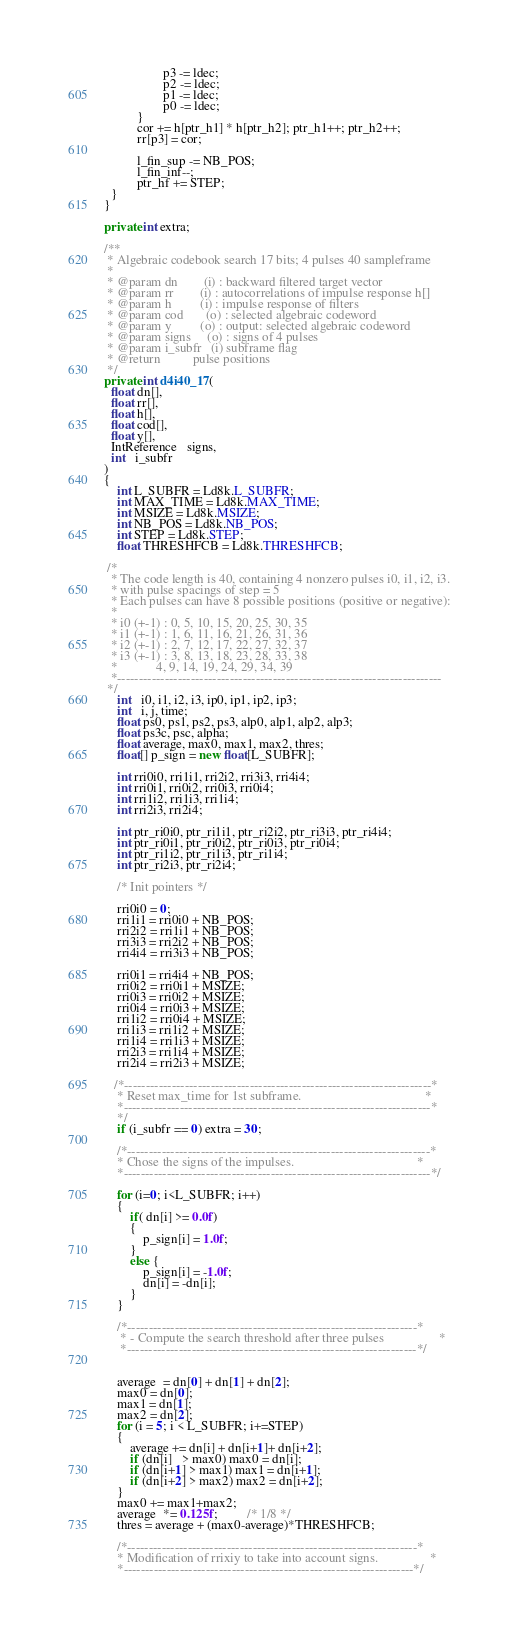<code> <loc_0><loc_0><loc_500><loc_500><_Java_>
                  p3 -= ldec;
                  p2 -= ldec;
                  p1 -= ldec;
                  p0 -= ldec;
          }
          cor += h[ptr_h1] * h[ptr_h2]; ptr_h1++; ptr_h2++;
          rr[p3] = cor;

          l_fin_sup -= NB_POS;
          l_fin_inf--;
          ptr_hf += STEP;
  }
}

private int extra;

/**
 * Algebraic codebook search 17 bits; 4 pulses 40 sampleframe
 *
 * @param dn        (i) : backward filtered target vector
 * @param rr        (i) : autocorrelations of impulse response h[]
 * @param h         (i) : impulse response of filters
 * @param cod       (o) : selected algebraic codeword
 * @param y         (o) : output: selected algebraic codeword
 * @param signs     (o) : signs of 4 pulses
 * @param i_subfr   (i) subframe flag
 * @return          pulse positions
 */
private int d4i40_17(
  float dn[],
  float rr[],
  float h[],
  float cod[],
  float y[],
  IntReference   signs,
  int   i_subfr
)
{
    int L_SUBFR = Ld8k.L_SUBFR;
    int MAX_TIME = Ld8k.MAX_TIME;
    int MSIZE = Ld8k.MSIZE;
    int NB_POS = Ld8k.NB_POS;
    int STEP = Ld8k.STEP;
    float THRESHFCB = Ld8k.THRESHFCB;

 /*
  * The code length is 40, containing 4 nonzero pulses i0, i1, i2, i3.
  * with pulse spacings of step = 5
  * Each pulses can have 8 possible positions (positive or negative):
  *
  * i0 (+-1) : 0, 5, 10, 15, 20, 25, 30, 35
  * i1 (+-1) : 1, 6, 11, 16, 21, 26, 31, 36
  * i2 (+-1) : 2, 7, 12, 17, 22, 27, 32, 37
  * i3 (+-1) : 3, 8, 13, 18, 23, 28, 33, 38
  *            4, 9, 14, 19, 24, 29, 34, 39
  *---------------------------------------------------------------------------
 */
    int   i0, i1, i2, i3, ip0, ip1, ip2, ip3;
    int   i, j, time;
    float ps0, ps1, ps2, ps3, alp0, alp1, alp2, alp3;
    float ps3c, psc, alpha;
    float average, max0, max1, max2, thres;
    float[] p_sign = new float[L_SUBFR];

    int rri0i0, rri1i1, rri2i2, rri3i3, rri4i4;
    int rri0i1, rri0i2, rri0i3, rri0i4;
    int rri1i2, rri1i3, rri1i4;
    int rri2i3, rri2i4;

    int ptr_ri0i0, ptr_ri1i1, ptr_ri2i2, ptr_ri3i3, ptr_ri4i4;
    int ptr_ri0i1, ptr_ri0i2, ptr_ri0i3, ptr_ri0i4;
    int ptr_ri1i2, ptr_ri1i3, ptr_ri1i4;
    int ptr_ri2i3, ptr_ri2i4;

    /* Init pointers */

    rri0i0 = 0;
    rri1i1 = rri0i0 + NB_POS;
    rri2i2 = rri1i1 + NB_POS;
    rri3i3 = rri2i2 + NB_POS;
    rri4i4 = rri3i3 + NB_POS;

    rri0i1 = rri4i4 + NB_POS;
    rri0i2 = rri0i1 + MSIZE;
    rri0i3 = rri0i2 + MSIZE;
    rri0i4 = rri0i3 + MSIZE;
    rri1i2 = rri0i4 + MSIZE;
    rri1i3 = rri1i2 + MSIZE;
    rri1i4 = rri1i3 + MSIZE;
    rri2i3 = rri1i4 + MSIZE;
    rri2i4 = rri2i3 + MSIZE;

   /*-----------------------------------------------------------------------*
    * Reset max_time for 1st subframe.                                      *
    *-----------------------------------------------------------------------*
    */
    if (i_subfr == 0) extra = 30;

    /*----------------------------------------------------------------------*
    * Chose the signs of the impulses.                                      *
    *-----------------------------------------------------------------------*/

    for (i=0; i<L_SUBFR; i++)
    {
        if( dn[i] >= 0.0f)
        {
            p_sign[i] = 1.0f;
        }
        else {
            p_sign[i] = -1.0f;
            dn[i] = -dn[i];
        }
    }

    /*-------------------------------------------------------------------*
     * - Compute the search threshold after three pulses                 *
     *-------------------------------------------------------------------*/


    average  = dn[0] + dn[1] + dn[2];
    max0 = dn[0];
    max1 = dn[1];
    max2 = dn[2];
    for (i = 5; i < L_SUBFR; i+=STEP)
    {
        average += dn[i] + dn[i+1]+ dn[i+2];
        if (dn[i]   > max0) max0 = dn[i];
        if (dn[i+1] > max1) max1 = dn[i+1];
        if (dn[i+2] > max2) max2 = dn[i+2];
    }
    max0 += max1+max2;
    average  *= 0.125f;         /* 1/8 */
    thres = average + (max0-average)*THRESHFCB;

    /*-------------------------------------------------------------------*
    * Modification of rrixiy to take into account signs.                *
    *-------------------------------------------------------------------*/</code> 